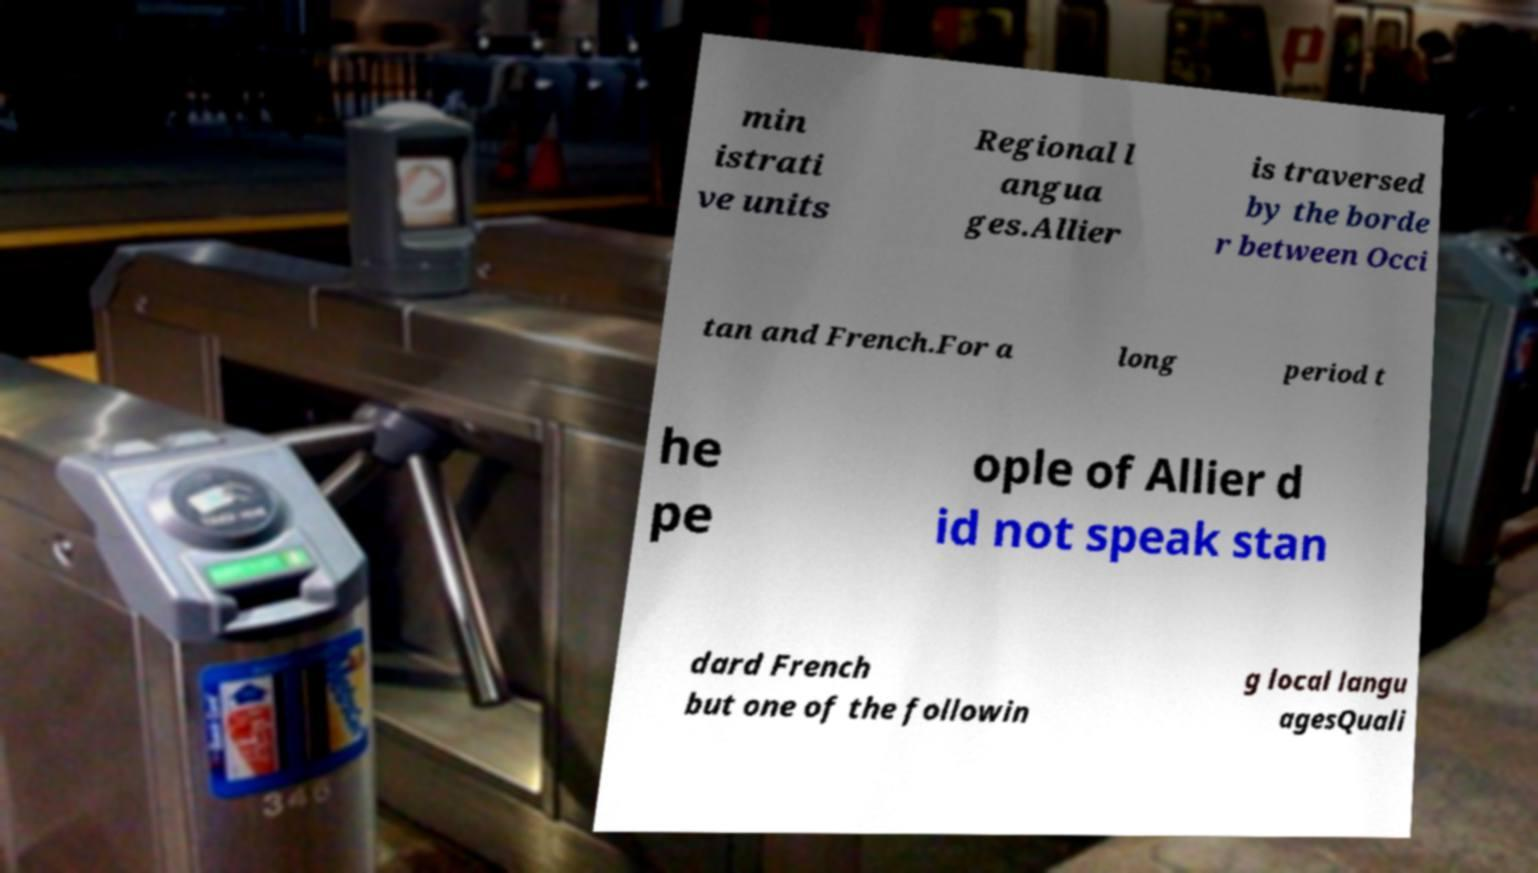Could you extract and type out the text from this image? min istrati ve units Regional l angua ges.Allier is traversed by the borde r between Occi tan and French.For a long period t he pe ople of Allier d id not speak stan dard French but one of the followin g local langu agesQuali 